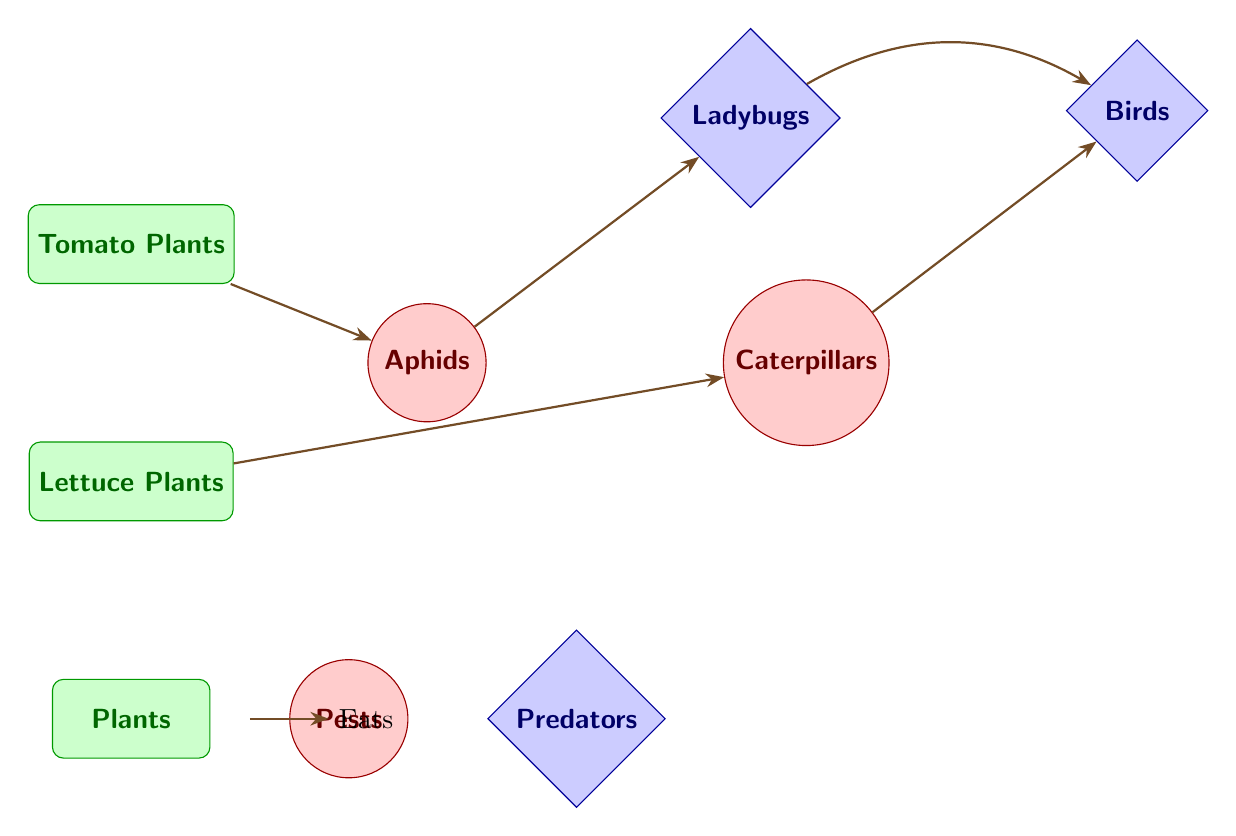What is eating the tomato plants? The diagram shows an arrow from the "Tomato Plants" node to the "Aphids" node, indicating that aphids are feeding on tomato plants.
Answer: Aphids How many types of predators are shown? There are two distinct predator nodes in the diagram: "Ladybugs" and "Birds," so this indicates there are two types of predators present.
Answer: 2 Which pest is associated with lettuce plants? The diagram directly connects the "Lettuce Plants" to the "Caterpillars" node, indicating that caterpillars are the pests feeding on lettuce plants.
Answer: Caterpillars What do ladybugs eat? The diagram has an arrow pointing from the "Aphids" node to the "Ladybugs" node, indicating that ladybugs feed on aphids.
Answer: Aphids Which predator has a direct connection to caterpillars? The "Birds" node has an arrow coming from the "Caterpillars" node, showing that birds are the predators that feed on caterpillars.
Answer: Birds What is the relationship between ladybugs and birds? The diagram shows a connection from "Ladybugs" to "Birds" with a bent arrow, indicating that ladybugs and birds have a relationship in the food chain, but ladybugs do not prey on birds; rather, they coexist in the garden as both help control pests.
Answer: Coexistence Which plant do aphids primarily affect? The arrow from "Tomato Plants" to "Aphids" indicates that aphids primarily affect the tomato plants, as it directly connects them in the diagram.
Answer: Tomato Plants What type of diagram is this? The overall structure of the diagram, which depicts a flow of eating relationships between plants, pests, and predators, qualifies it as a food chain diagram.
Answer: Food chain What color represents pests in the diagram? The pests in the diagram are represented by red, as evidenced by the red fill in the pest nodes.
Answer: Red 